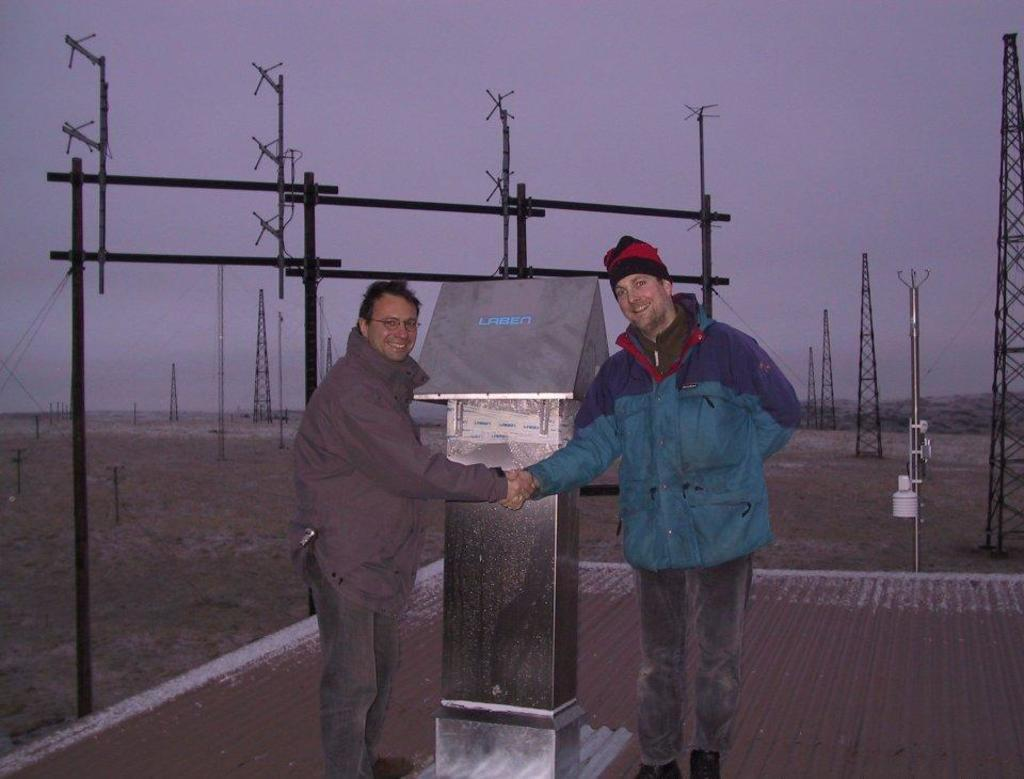How many people are in the image? There are two people in the image. What are the two people doing in the image? The two people are standing together and shaking hands. What can be seen in the background of the image? There is a pillar in the background of the image. What is present on the ground in the image? There are electrical poles on the ground in the image. How many boys are on the voyage depicted in the image? There is no voyage or boys present in the image; it features two people shaking hands with a pillar and electrical poles in the background. 